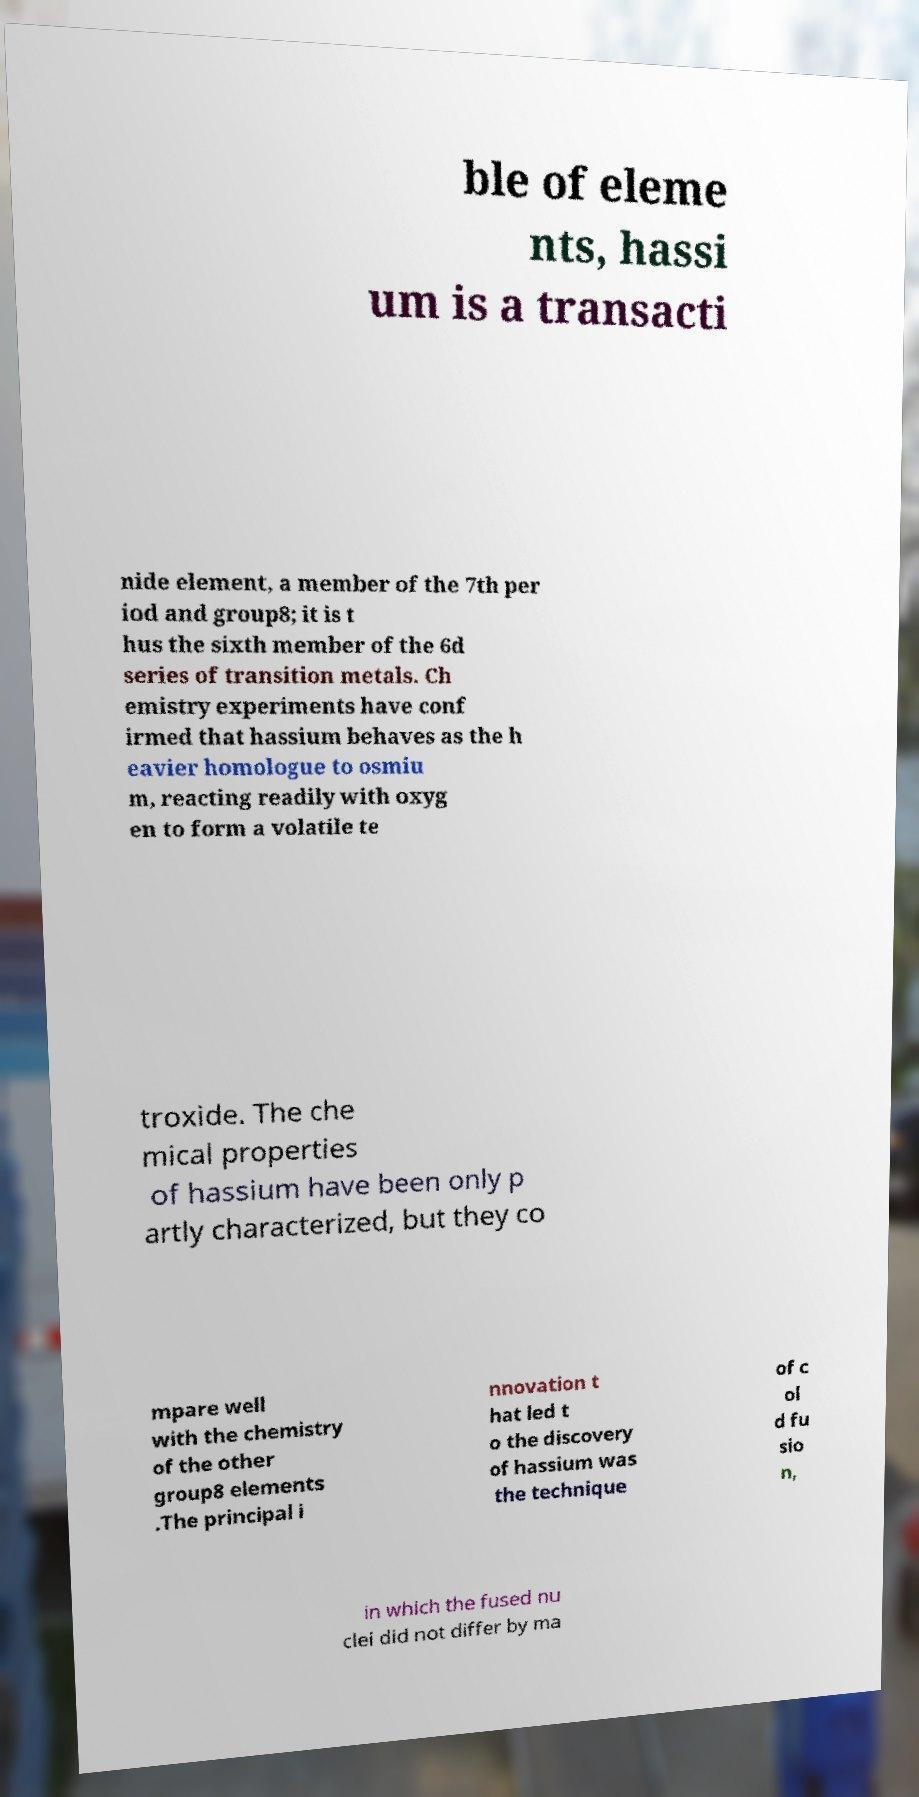Can you read and provide the text displayed in the image?This photo seems to have some interesting text. Can you extract and type it out for me? ble of eleme nts, hassi um is a transacti nide element, a member of the 7th per iod and group8; it is t hus the sixth member of the 6d series of transition metals. Ch emistry experiments have conf irmed that hassium behaves as the h eavier homologue to osmiu m, reacting readily with oxyg en to form a volatile te troxide. The che mical properties of hassium have been only p artly characterized, but they co mpare well with the chemistry of the other group8 elements .The principal i nnovation t hat led t o the discovery of hassium was the technique of c ol d fu sio n, in which the fused nu clei did not differ by ma 